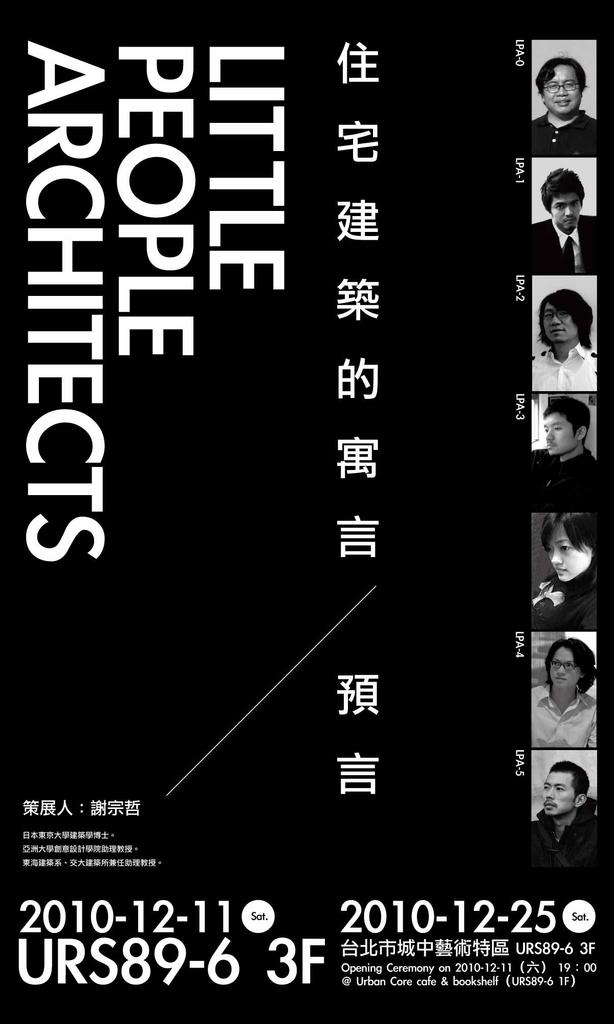<image>
Present a compact description of the photo's key features. A black catalog book with the title "Little People Architects" written vertically on it. 